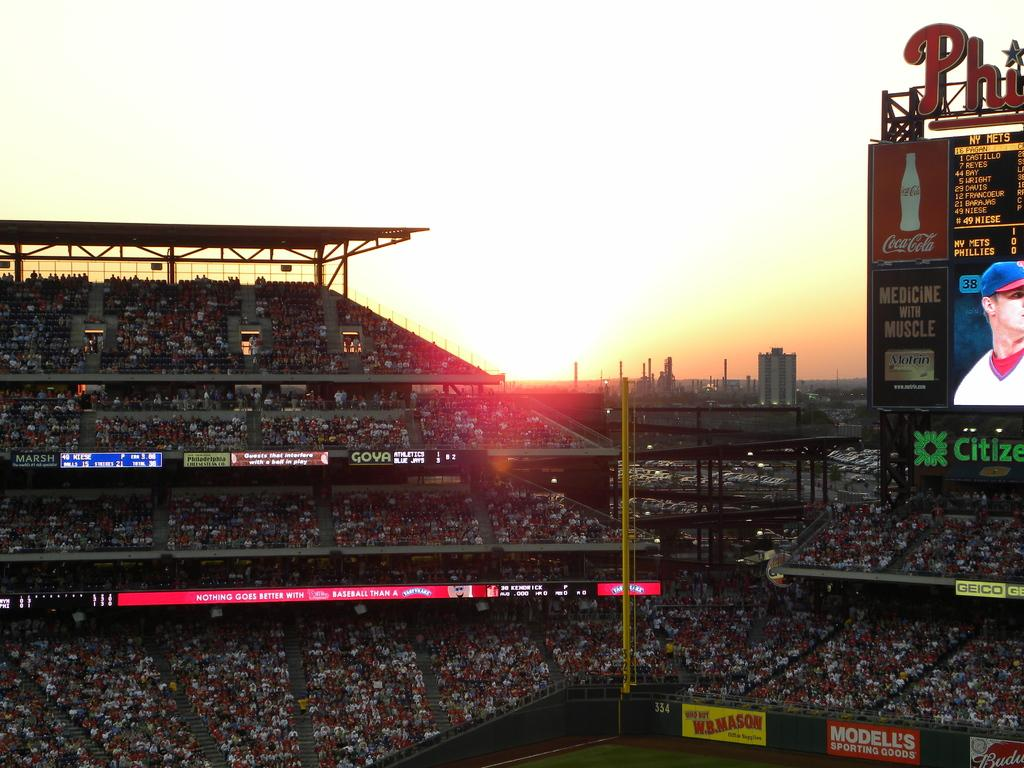<image>
Write a terse but informative summary of the picture. A baseball field has a Coca-Cola advertisement near the digital scoreboard. 